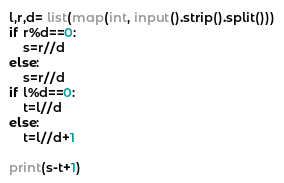<code> <loc_0><loc_0><loc_500><loc_500><_Python_>l,r,d= list(map(int, input().strip().split()))
if r%d==0:
    s=r//d
else:
    s=r//d
if l%d==0:
    t=l//d
else:
    t=l//d+1
    
print(s-t+1)</code> 